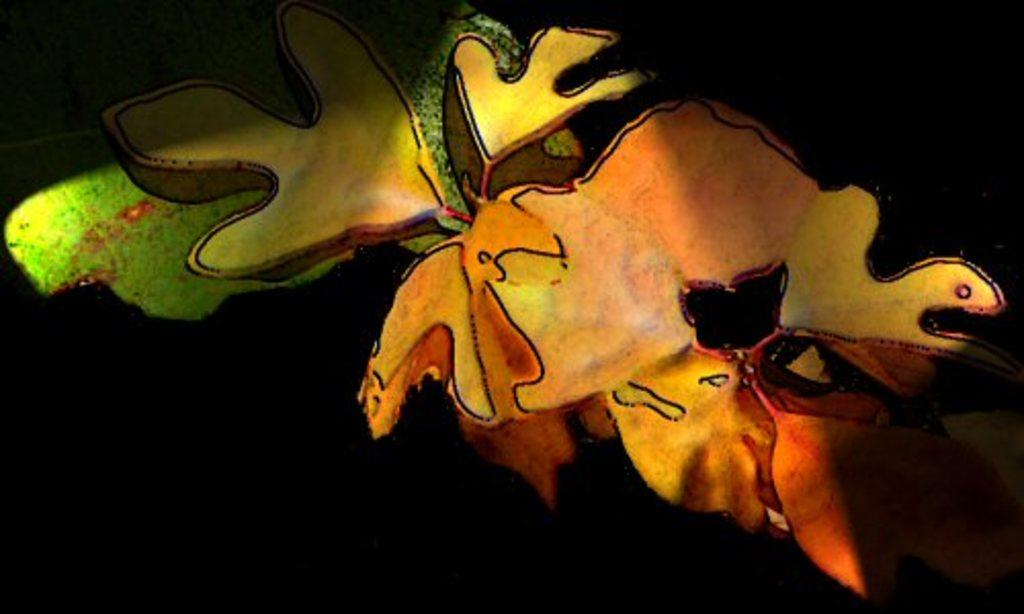What is happening in the image? There is an art presentation in the image. Can you describe the setting of the art presentation? Unfortunately, the facts provided do not give enough information to describe the setting of the art presentation. Are there any specific art pieces or artists mentioned in the image? The facts provided do not mention any specific art pieces or artists. What type of caption is written on the rose in the image? There is no rose or caption present in the image; it features an art presentation. Can you hear the sound of thunder during the art presentation in the image? The facts provided do not mention any sounds or weather conditions, so it is not possible to determine if there is thunder during the art presentation. 